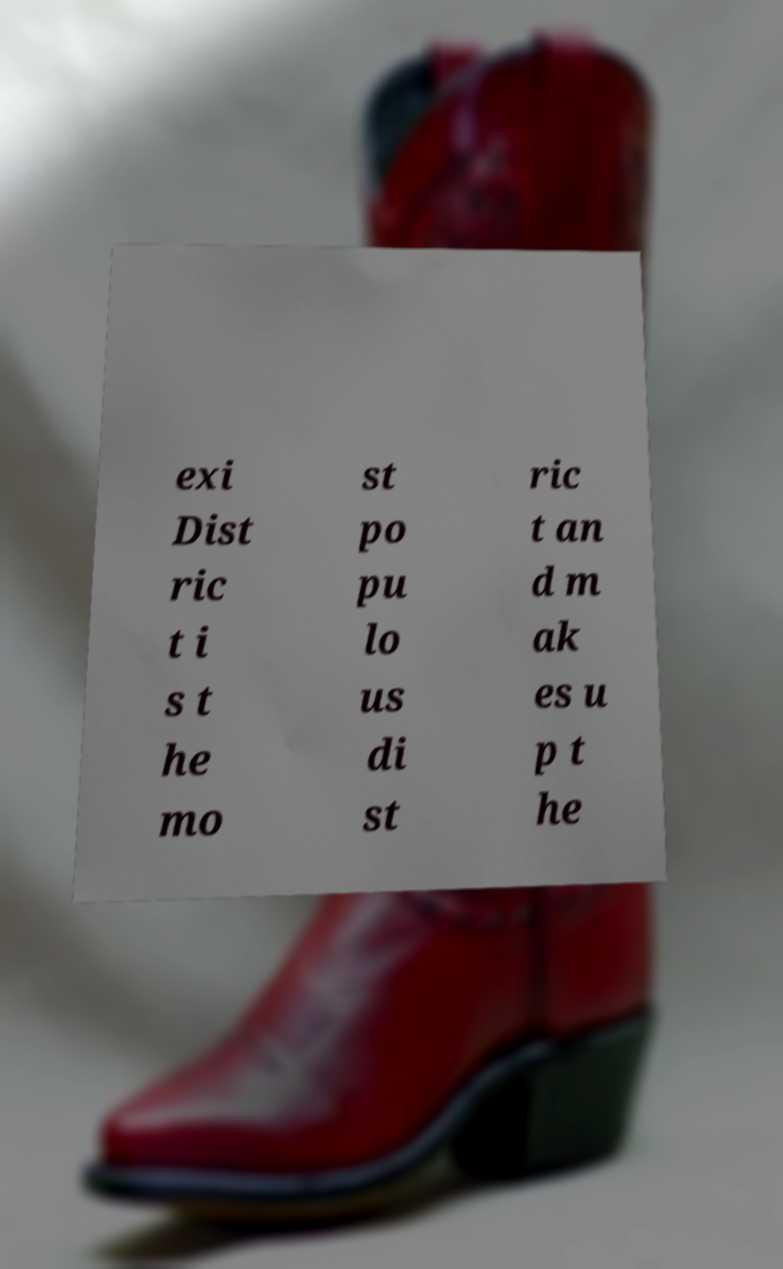Please identify and transcribe the text found in this image. exi Dist ric t i s t he mo st po pu lo us di st ric t an d m ak es u p t he 